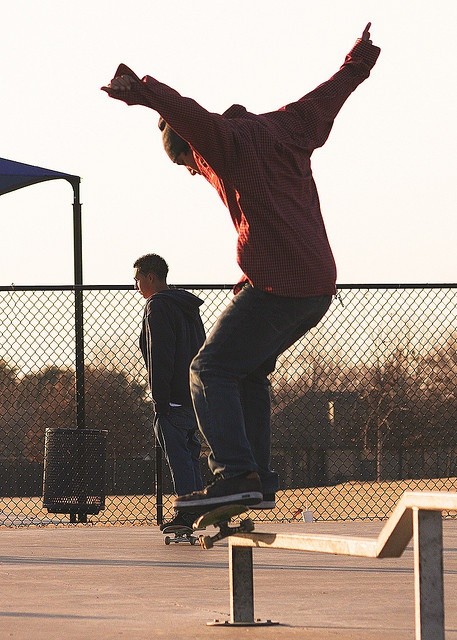Describe the objects in this image and their specific colors. I can see people in white, black, maroon, gray, and brown tones, people in white, black, maroon, gray, and darkgray tones, skateboard in white, black, maroon, and gray tones, and skateboard in white, black, and gray tones in this image. 